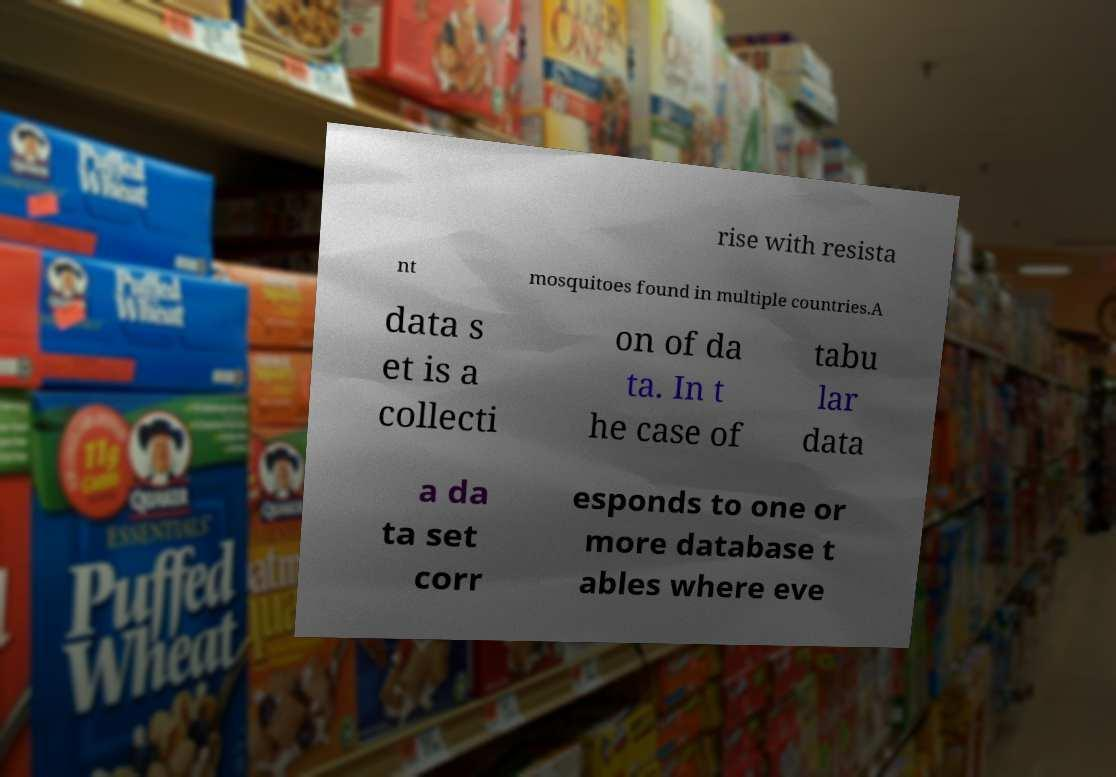Please read and relay the text visible in this image. What does it say? rise with resista nt mosquitoes found in multiple countries.A data s et is a collecti on of da ta. In t he case of tabu lar data a da ta set corr esponds to one or more database t ables where eve 